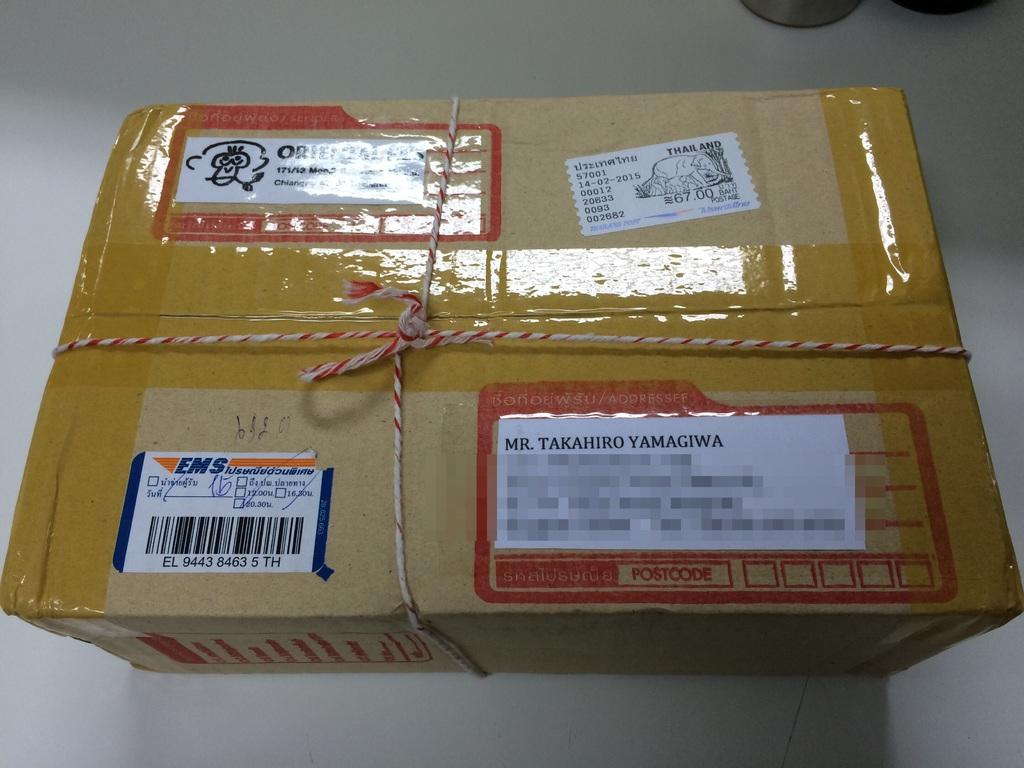<image>
Describe the image concisely. a box that is being shipped to mr. takahiro yamagiwa 